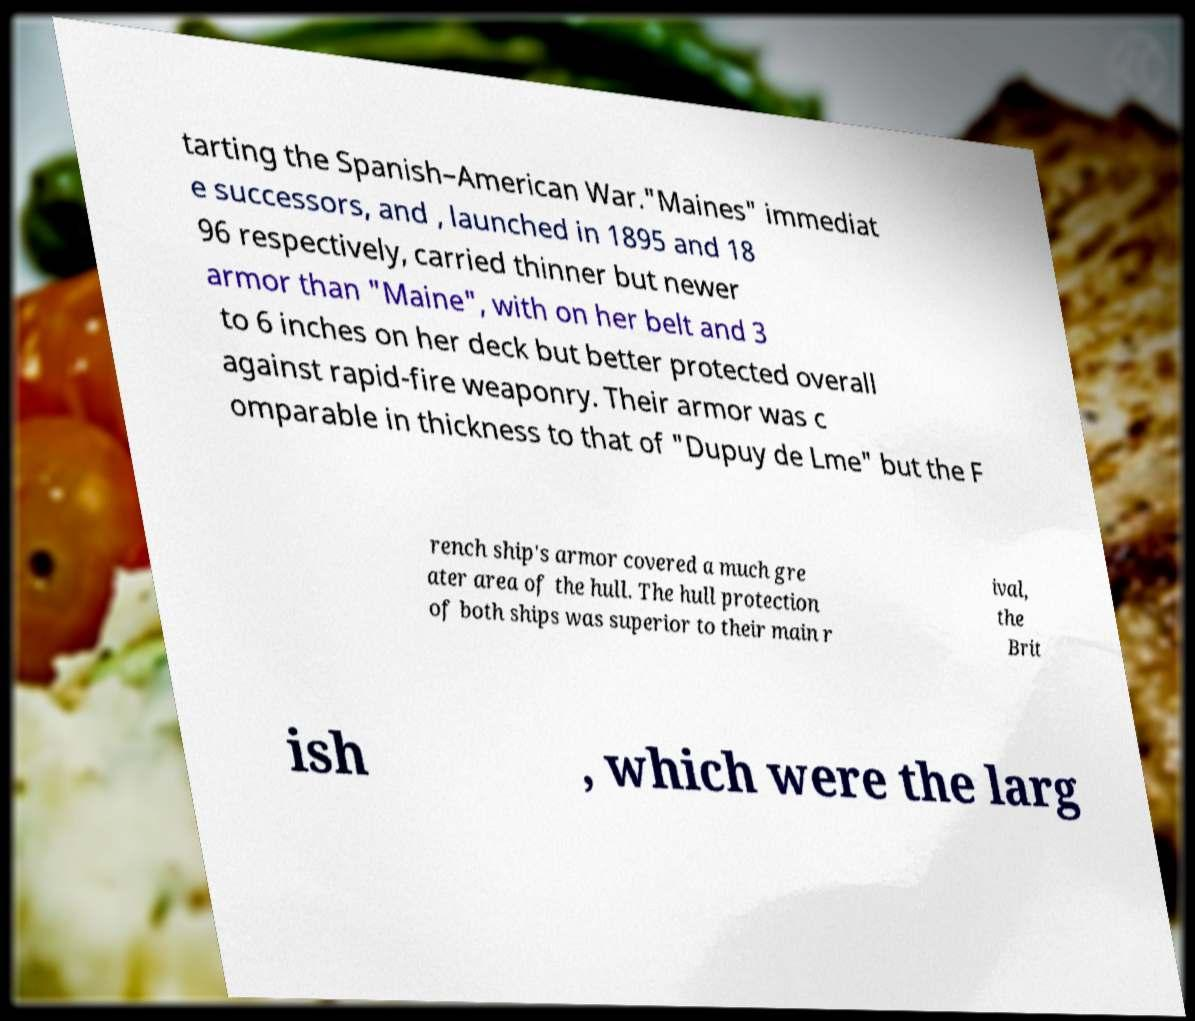Please identify and transcribe the text found in this image. tarting the Spanish–American War."Maines" immediat e successors, and , launched in 1895 and 18 96 respectively, carried thinner but newer armor than "Maine", with on her belt and 3 to 6 inches on her deck but better protected overall against rapid-fire weaponry. Their armor was c omparable in thickness to that of "Dupuy de Lme" but the F rench ship's armor covered a much gre ater area of the hull. The hull protection of both ships was superior to their main r ival, the Brit ish , which were the larg 